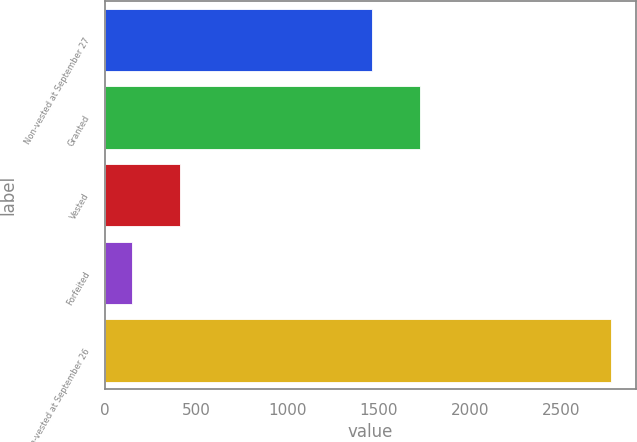<chart> <loc_0><loc_0><loc_500><loc_500><bar_chart><fcel>Non-vested at September 27<fcel>Granted<fcel>Vested<fcel>Forfeited<fcel>Non-vested at September 26<nl><fcel>1461<fcel>1723<fcel>412<fcel>150<fcel>2770<nl></chart> 